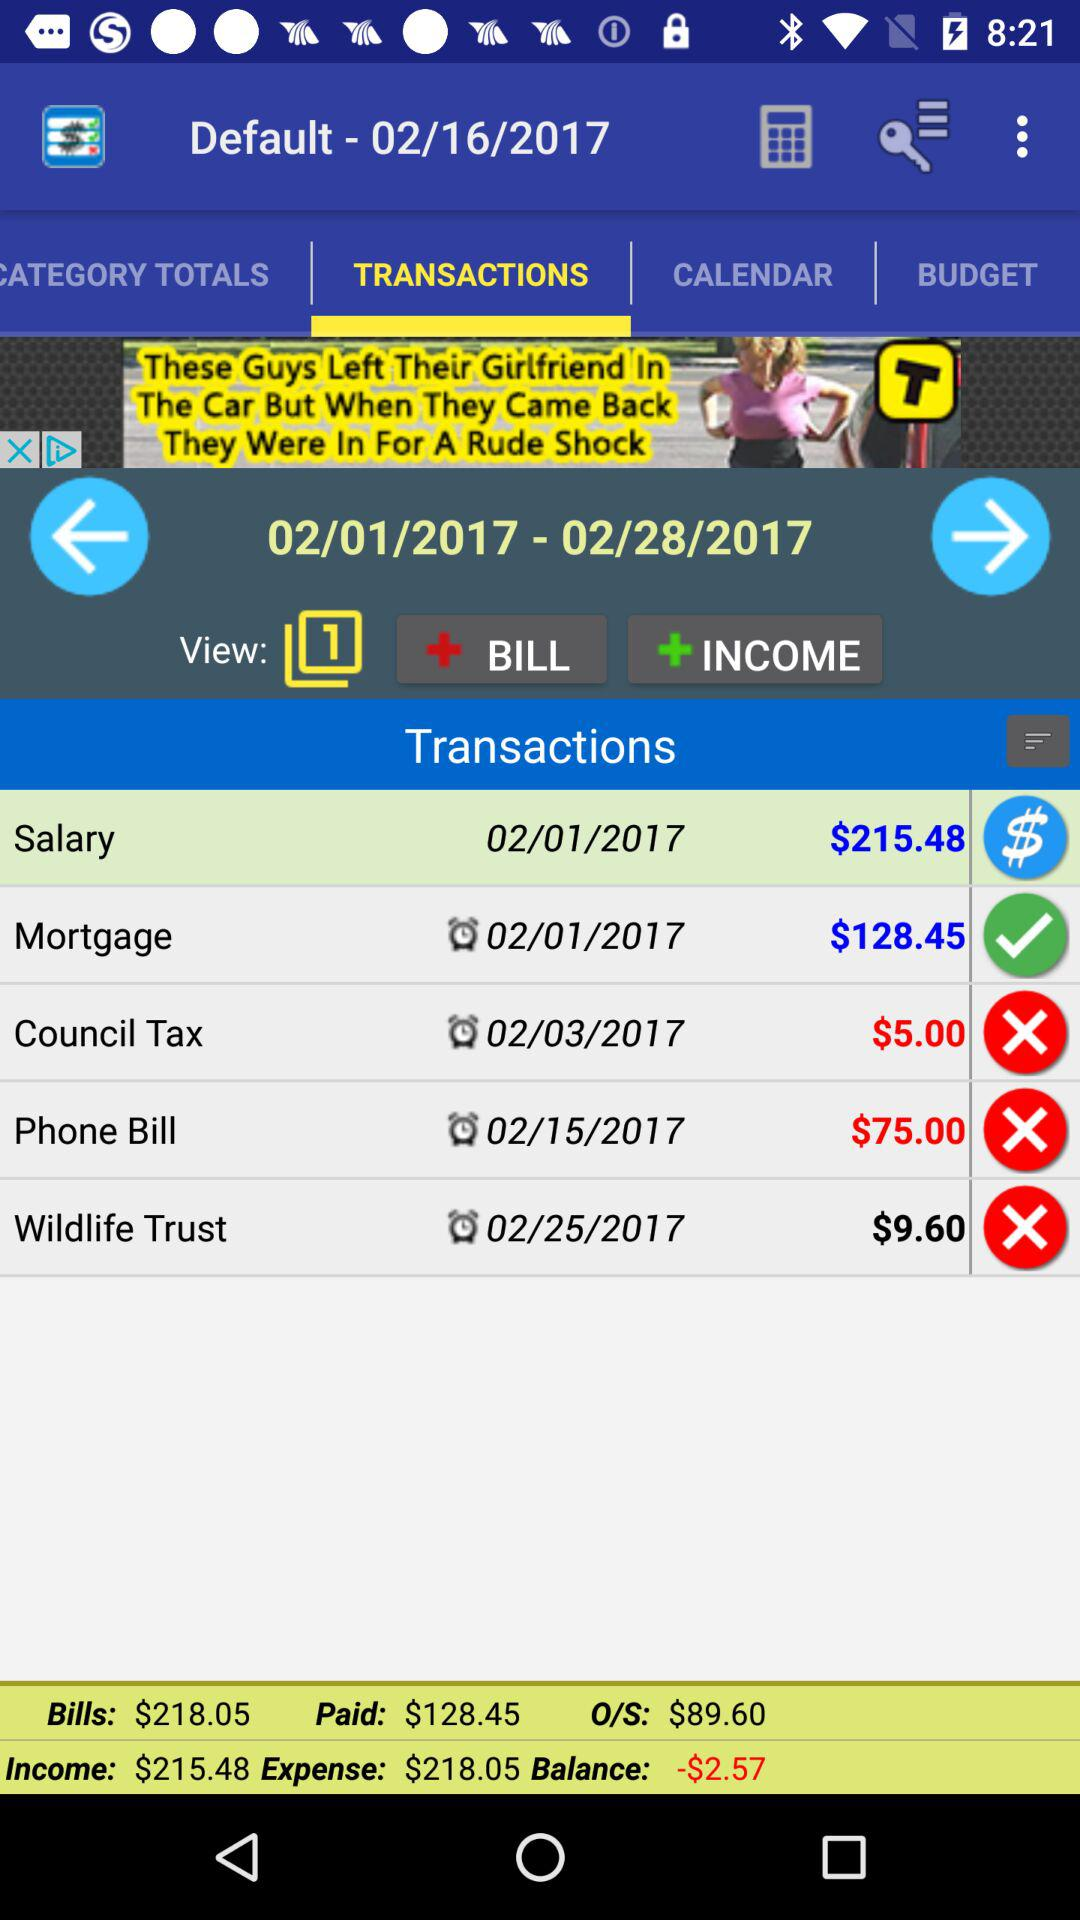What is the total amount of money spent on bills?
Answer the question using a single word or phrase. $218.05 